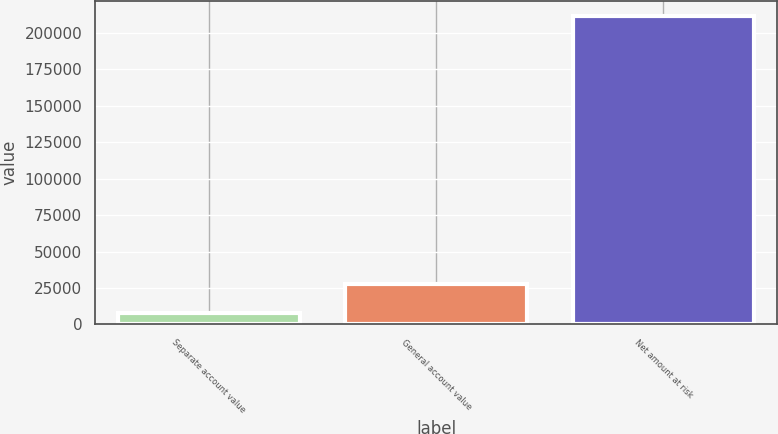Convert chart. <chart><loc_0><loc_0><loc_500><loc_500><bar_chart><fcel>Separate account value<fcel>General account value<fcel>Net amount at risk<nl><fcel>7643<fcel>28021.5<fcel>211428<nl></chart> 